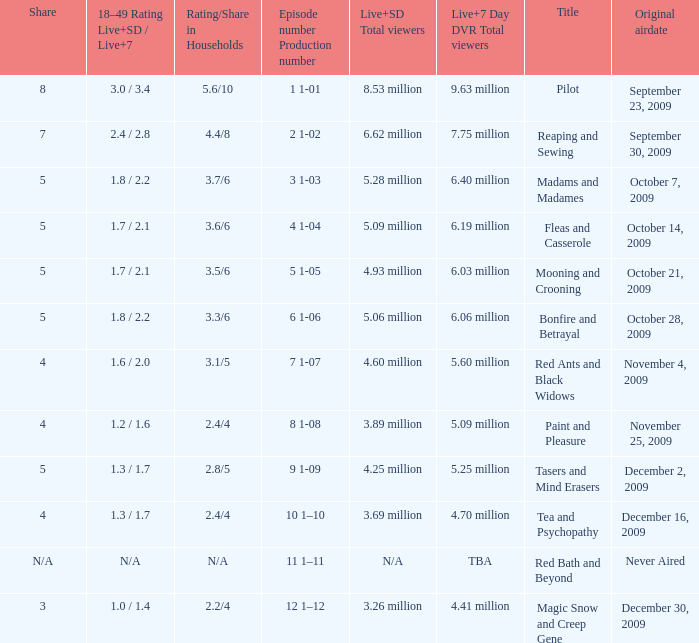How many total viewers (combined Live and SD) watched the episode with a share of 8? 9.63 million. 